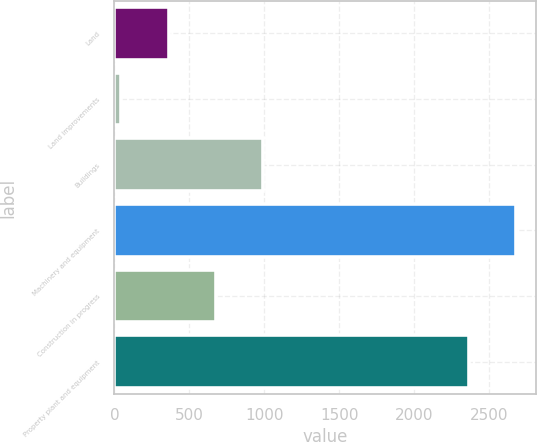Convert chart to OTSL. <chart><loc_0><loc_0><loc_500><loc_500><bar_chart><fcel>Land<fcel>Land improvements<fcel>Buildings<fcel>Machinery and equipment<fcel>Construction in progress<fcel>Property plant and equipment<nl><fcel>360.5<fcel>45<fcel>991.5<fcel>2677.5<fcel>676<fcel>2362<nl></chart> 